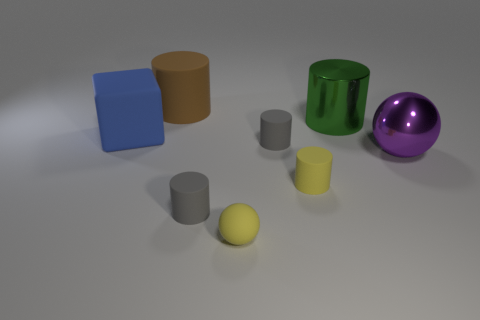Are there more cylindrical objects or cuboid objects displayed? There are more cylindrical objects in the image, amounting to three, whereas there are two cuboid shapes present. 